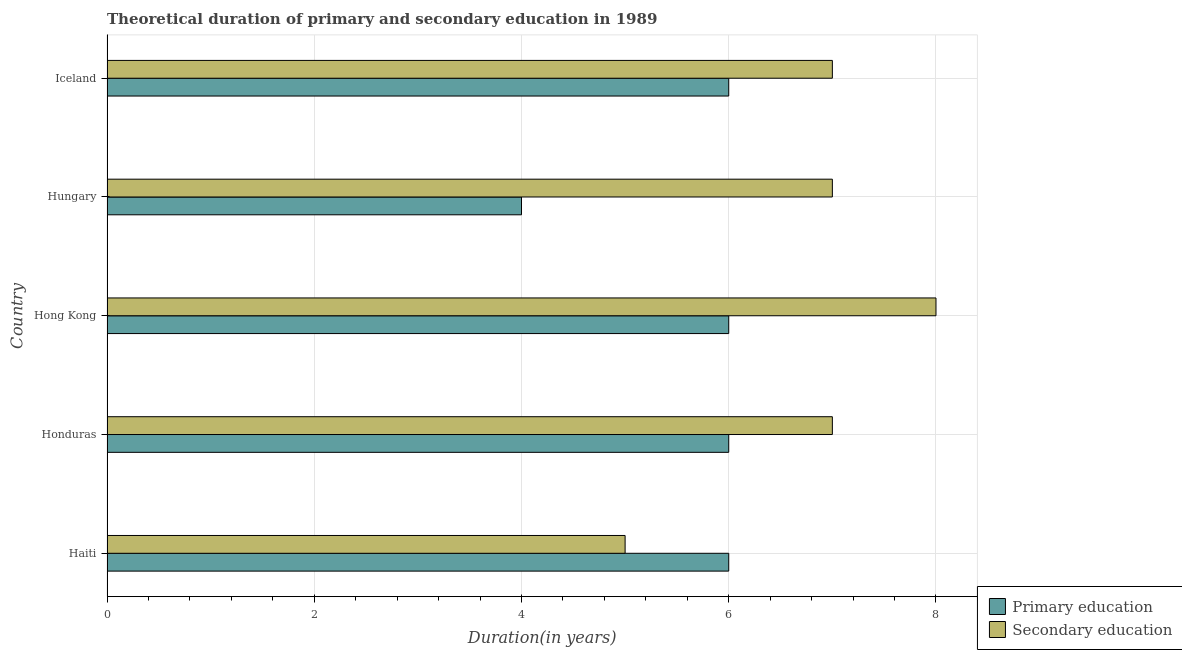How many different coloured bars are there?
Provide a short and direct response. 2. Are the number of bars on each tick of the Y-axis equal?
Your answer should be compact. Yes. How many bars are there on the 3rd tick from the top?
Your answer should be compact. 2. What is the label of the 3rd group of bars from the top?
Give a very brief answer. Hong Kong. What is the duration of secondary education in Haiti?
Provide a short and direct response. 5. Across all countries, what is the maximum duration of secondary education?
Your answer should be very brief. 8. Across all countries, what is the minimum duration of secondary education?
Give a very brief answer. 5. In which country was the duration of secondary education maximum?
Provide a short and direct response. Hong Kong. In which country was the duration of primary education minimum?
Make the answer very short. Hungary. What is the total duration of primary education in the graph?
Your answer should be very brief. 28. What is the difference between the duration of secondary education in Hungary and the duration of primary education in Hong Kong?
Offer a terse response. 1. What is the difference between the duration of primary education and duration of secondary education in Hong Kong?
Make the answer very short. -2. What is the ratio of the duration of secondary education in Haiti to that in Hungary?
Offer a terse response. 0.71. Is the difference between the duration of primary education in Haiti and Honduras greater than the difference between the duration of secondary education in Haiti and Honduras?
Your response must be concise. Yes. What is the difference between the highest and the lowest duration of primary education?
Keep it short and to the point. 2. In how many countries, is the duration of secondary education greater than the average duration of secondary education taken over all countries?
Ensure brevity in your answer.  4. Is the sum of the duration of primary education in Haiti and Hungary greater than the maximum duration of secondary education across all countries?
Your answer should be compact. Yes. What does the 2nd bar from the top in Honduras represents?
Provide a succinct answer. Primary education. What does the 2nd bar from the bottom in Hong Kong represents?
Keep it short and to the point. Secondary education. How many bars are there?
Offer a terse response. 10. Are all the bars in the graph horizontal?
Offer a terse response. Yes. How many countries are there in the graph?
Provide a short and direct response. 5. What is the difference between two consecutive major ticks on the X-axis?
Offer a very short reply. 2. How are the legend labels stacked?
Your answer should be very brief. Vertical. What is the title of the graph?
Make the answer very short. Theoretical duration of primary and secondary education in 1989. What is the label or title of the X-axis?
Your answer should be very brief. Duration(in years). What is the Duration(in years) in Secondary education in Haiti?
Keep it short and to the point. 5. What is the Duration(in years) of Secondary education in Honduras?
Ensure brevity in your answer.  7. What is the Duration(in years) of Primary education in Hong Kong?
Ensure brevity in your answer.  6. What is the Duration(in years) in Secondary education in Iceland?
Keep it short and to the point. 7. Across all countries, what is the minimum Duration(in years) of Secondary education?
Ensure brevity in your answer.  5. What is the total Duration(in years) of Primary education in the graph?
Your answer should be very brief. 28. What is the difference between the Duration(in years) in Primary education in Haiti and that in Honduras?
Keep it short and to the point. 0. What is the difference between the Duration(in years) of Primary education in Haiti and that in Hungary?
Keep it short and to the point. 2. What is the difference between the Duration(in years) of Primary education in Haiti and that in Iceland?
Provide a short and direct response. 0. What is the difference between the Duration(in years) in Secondary education in Haiti and that in Iceland?
Your answer should be compact. -2. What is the difference between the Duration(in years) in Primary education in Honduras and that in Hungary?
Provide a succinct answer. 2. What is the difference between the Duration(in years) of Primary education in Honduras and that in Iceland?
Provide a short and direct response. 0. What is the difference between the Duration(in years) in Primary education in Hong Kong and that in Hungary?
Provide a short and direct response. 2. What is the difference between the Duration(in years) in Secondary education in Hong Kong and that in Hungary?
Keep it short and to the point. 1. What is the difference between the Duration(in years) in Primary education in Haiti and the Duration(in years) in Secondary education in Honduras?
Your answer should be very brief. -1. What is the difference between the Duration(in years) in Primary education in Haiti and the Duration(in years) in Secondary education in Hungary?
Your answer should be very brief. -1. What is the difference between the Duration(in years) in Primary education in Haiti and the Duration(in years) in Secondary education in Iceland?
Make the answer very short. -1. What is the difference between the Duration(in years) in Primary education in Honduras and the Duration(in years) in Secondary education in Hong Kong?
Offer a terse response. -2. What is the difference between the Duration(in years) of Primary education in Honduras and the Duration(in years) of Secondary education in Iceland?
Offer a very short reply. -1. What is the difference between the Duration(in years) of Primary education in Hungary and the Duration(in years) of Secondary education in Iceland?
Offer a very short reply. -3. What is the average Duration(in years) of Secondary education per country?
Ensure brevity in your answer.  6.8. What is the difference between the Duration(in years) in Primary education and Duration(in years) in Secondary education in Honduras?
Keep it short and to the point. -1. What is the difference between the Duration(in years) in Primary education and Duration(in years) in Secondary education in Hong Kong?
Your response must be concise. -2. What is the difference between the Duration(in years) in Primary education and Duration(in years) in Secondary education in Hungary?
Keep it short and to the point. -3. What is the ratio of the Duration(in years) in Primary education in Haiti to that in Honduras?
Ensure brevity in your answer.  1. What is the ratio of the Duration(in years) of Secondary education in Haiti to that in Hong Kong?
Offer a very short reply. 0.62. What is the ratio of the Duration(in years) of Primary education in Haiti to that in Hungary?
Ensure brevity in your answer.  1.5. What is the ratio of the Duration(in years) in Secondary education in Haiti to that in Hungary?
Give a very brief answer. 0.71. What is the ratio of the Duration(in years) of Primary education in Haiti to that in Iceland?
Offer a very short reply. 1. What is the ratio of the Duration(in years) of Secondary education in Haiti to that in Iceland?
Provide a succinct answer. 0.71. What is the ratio of the Duration(in years) of Primary education in Honduras to that in Hong Kong?
Your answer should be very brief. 1. What is the ratio of the Duration(in years) of Primary education in Honduras to that in Iceland?
Offer a terse response. 1. What is the ratio of the Duration(in years) in Secondary education in Hong Kong to that in Iceland?
Make the answer very short. 1.14. What is the ratio of the Duration(in years) of Secondary education in Hungary to that in Iceland?
Your answer should be compact. 1. What is the difference between the highest and the second highest Duration(in years) of Primary education?
Offer a very short reply. 0. What is the difference between the highest and the second highest Duration(in years) of Secondary education?
Make the answer very short. 1. 